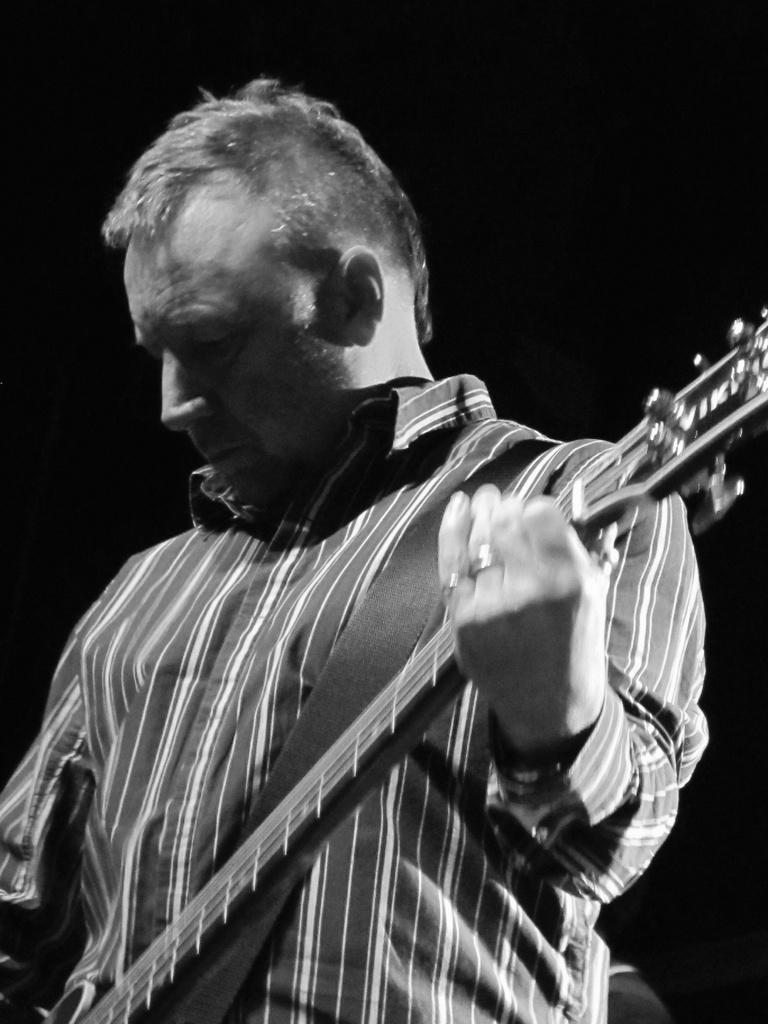What is the person in the image doing? The person is playing the guitar. What instrument is the person holding? The person is holding a guitar. What is the person wearing in the image? The person is wearing a black check shirt with colorful patterns. How many babies can be seen in the image? There are no babies present in the image. What type of nail is the person using to play the guitar? The person is not using a nail to play the guitar; they are using their fingers or a guitar pick. 